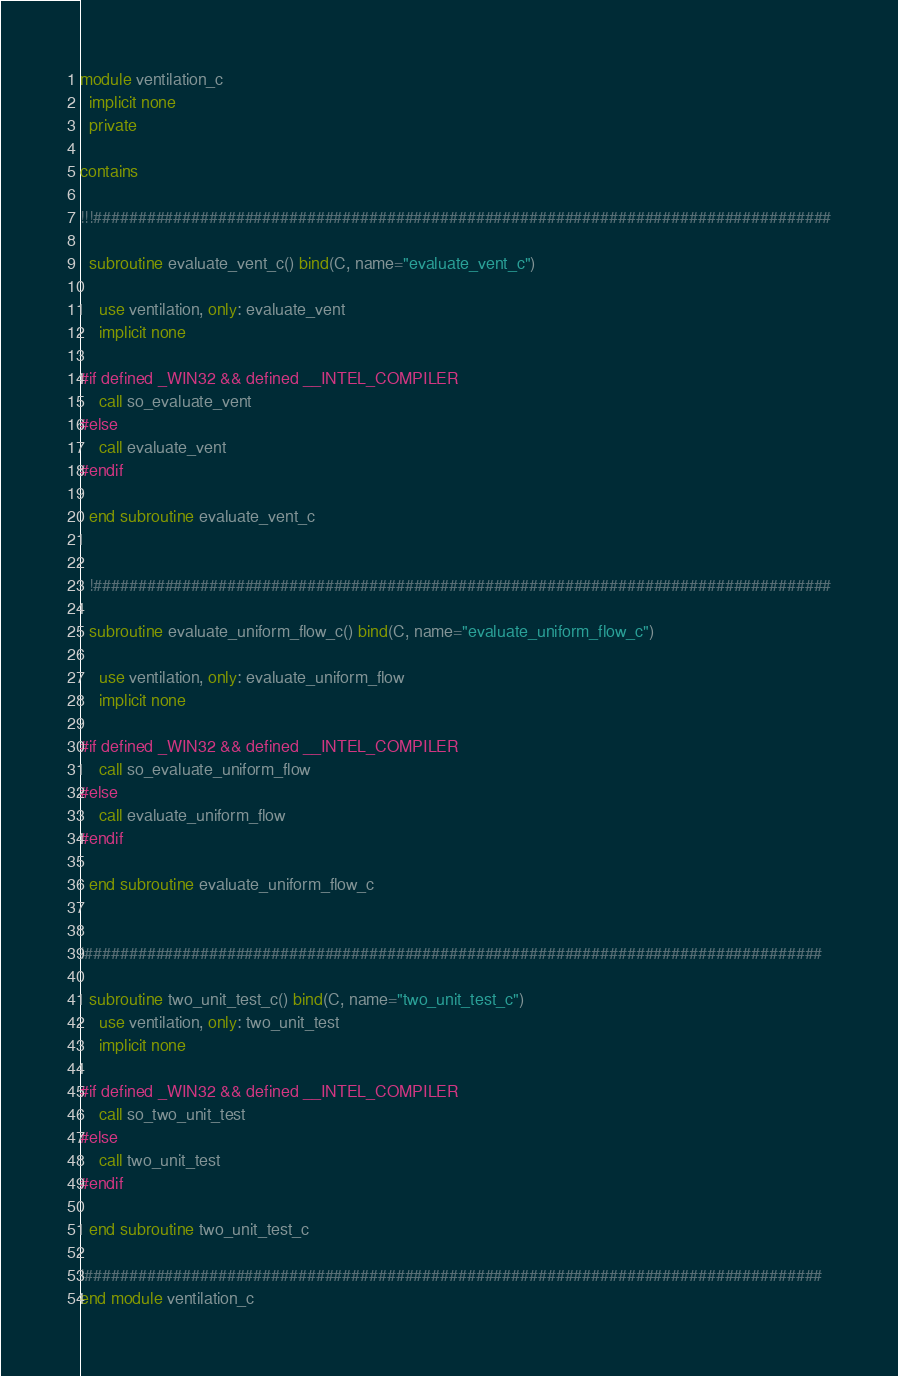<code> <loc_0><loc_0><loc_500><loc_500><_FORTRAN_>module ventilation_c
  implicit none
  private

contains

!!!###################################################################################

  subroutine evaluate_vent_c() bind(C, name="evaluate_vent_c")

    use ventilation, only: evaluate_vent
    implicit none

#if defined _WIN32 && defined __INTEL_COMPILER
    call so_evaluate_vent
#else
    call evaluate_vent
#endif

  end subroutine evaluate_vent_c


  !###################################################################################

  subroutine evaluate_uniform_flow_c() bind(C, name="evaluate_uniform_flow_c")

    use ventilation, only: evaluate_uniform_flow
    implicit none

#if defined _WIN32 && defined __INTEL_COMPILER
    call so_evaluate_uniform_flow
#else
    call evaluate_uniform_flow
#endif

  end subroutine evaluate_uniform_flow_c


!###################################################################################

  subroutine two_unit_test_c() bind(C, name="two_unit_test_c")
    use ventilation, only: two_unit_test
    implicit none

#if defined _WIN32 && defined __INTEL_COMPILER
    call so_two_unit_test
#else
    call two_unit_test
#endif

  end subroutine two_unit_test_c

!###################################################################################
end module ventilation_c
</code> 